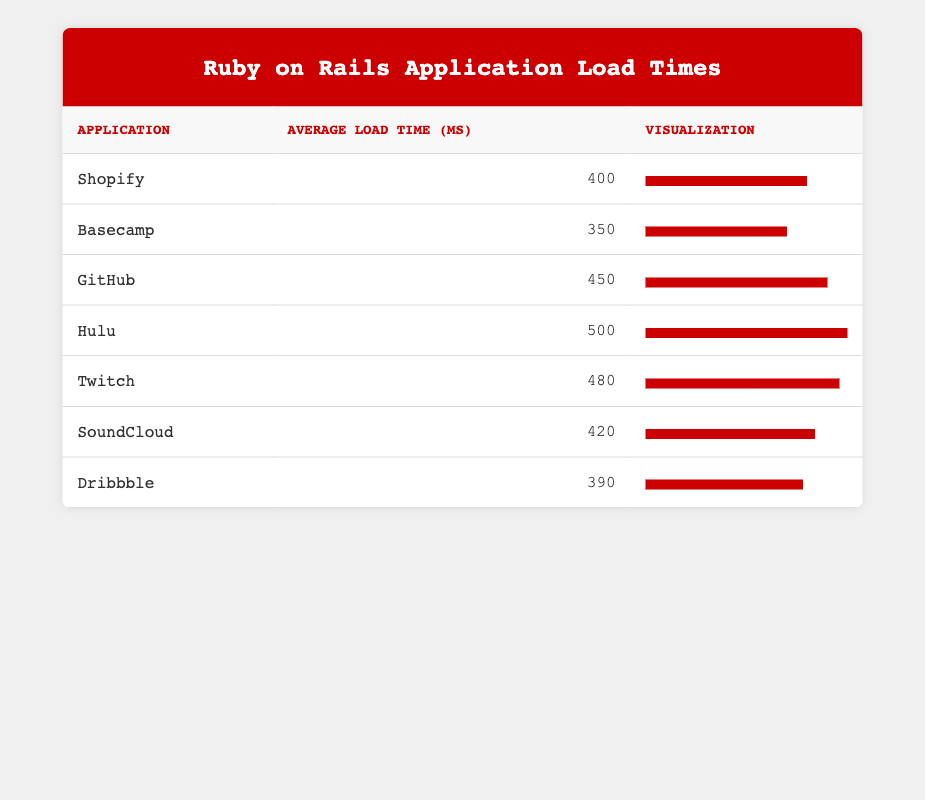What is the average page load time for Shopify? The table lists the average page load time for Shopify as 400 milliseconds.
Answer: 400 Which application has the highest average load time? By examining the table for the average load times, Hulu has the highest average load time at 500 milliseconds.
Answer: Hulu What is the average page load time for all listed applications? First, we sum the average load times: (400 + 350 + 450 + 500 + 480 + 420 + 390) = 2970. There are 7 applications, so we calculate the average: 2970 / 7 = 423.
Answer: 423 Is the average load time for SoundCloud more than 400 milliseconds? The average load time for SoundCloud is 420 milliseconds, which is indeed more than 400 milliseconds.
Answer: Yes What is the difference in average load time between the fastest (Basecamp) and the slowest (Hulu) applications? The average load time for Basecamp is 350 milliseconds, and for Hulu, it is 500 milliseconds. The difference is 500 - 350 = 150 milliseconds.
Answer: 150 How many applications have an average load time above 450 milliseconds? By reviewing the table, the applications with average load times above 450 milliseconds are Hulu (500) and Twitch (480). Therefore, there are 2 applications.
Answer: 2 What is the median average load time of the applications listed? To find the median, we first list the average load times in ascending order: 350, 390, 400, 420, 450, 480, 500. Since there are 7 numbers, the median is the 4th number, which is 420 milliseconds.
Answer: 420 How does the average load time for GitHub compare to the average load time for SoundCloud? GitHub's average load time is 450 milliseconds, and SoundCloud's average load time is 420 milliseconds. Comparing both, GitHub is faster by 30 milliseconds.
Answer: GitHub is faster by 30 milliseconds How many applications have an average load time of less than 400 milliseconds? The applications below 400 milliseconds are Basecamp (350) and Dribbble (390), totaling 2 applications with load times less than 400 milliseconds.
Answer: 2 